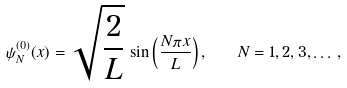Convert formula to latex. <formula><loc_0><loc_0><loc_500><loc_500>\psi ^ { ( 0 ) } _ { N } ( x ) = \sqrt { \frac { 2 } { L } } \, \sin \left ( \frac { N \pi x } { L } \right ) , \quad N = 1 , 2 , 3 , \dots \, ,</formula> 